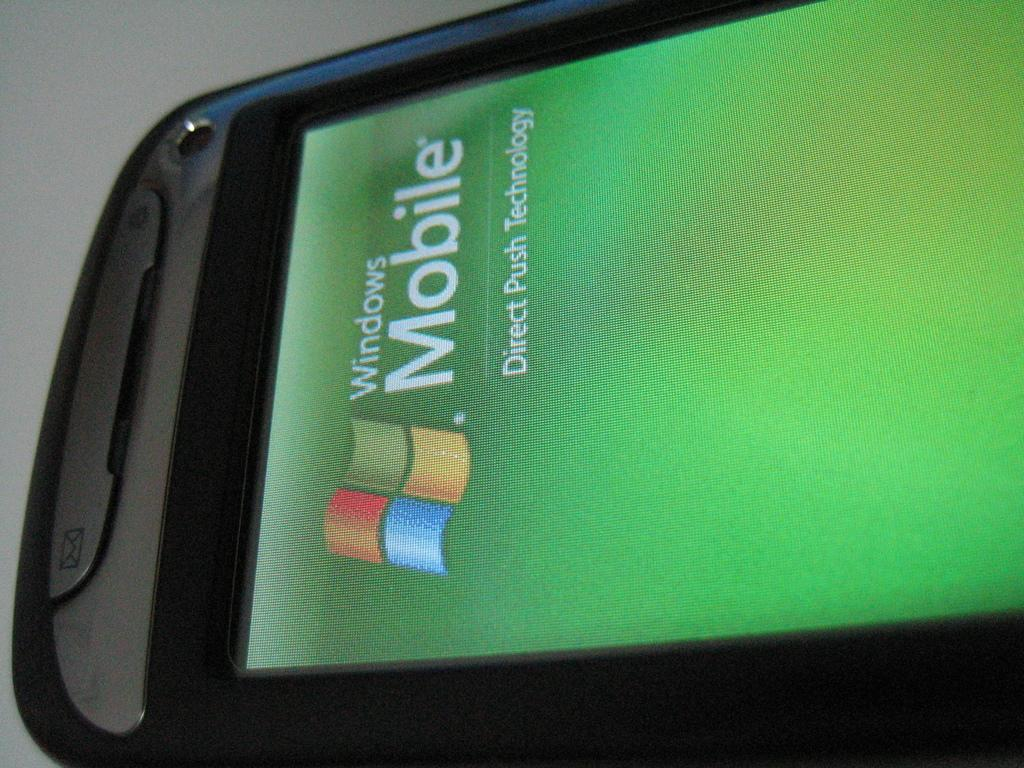<image>
Describe the image concisely. The screen of a windows mobile branded cell phone. 